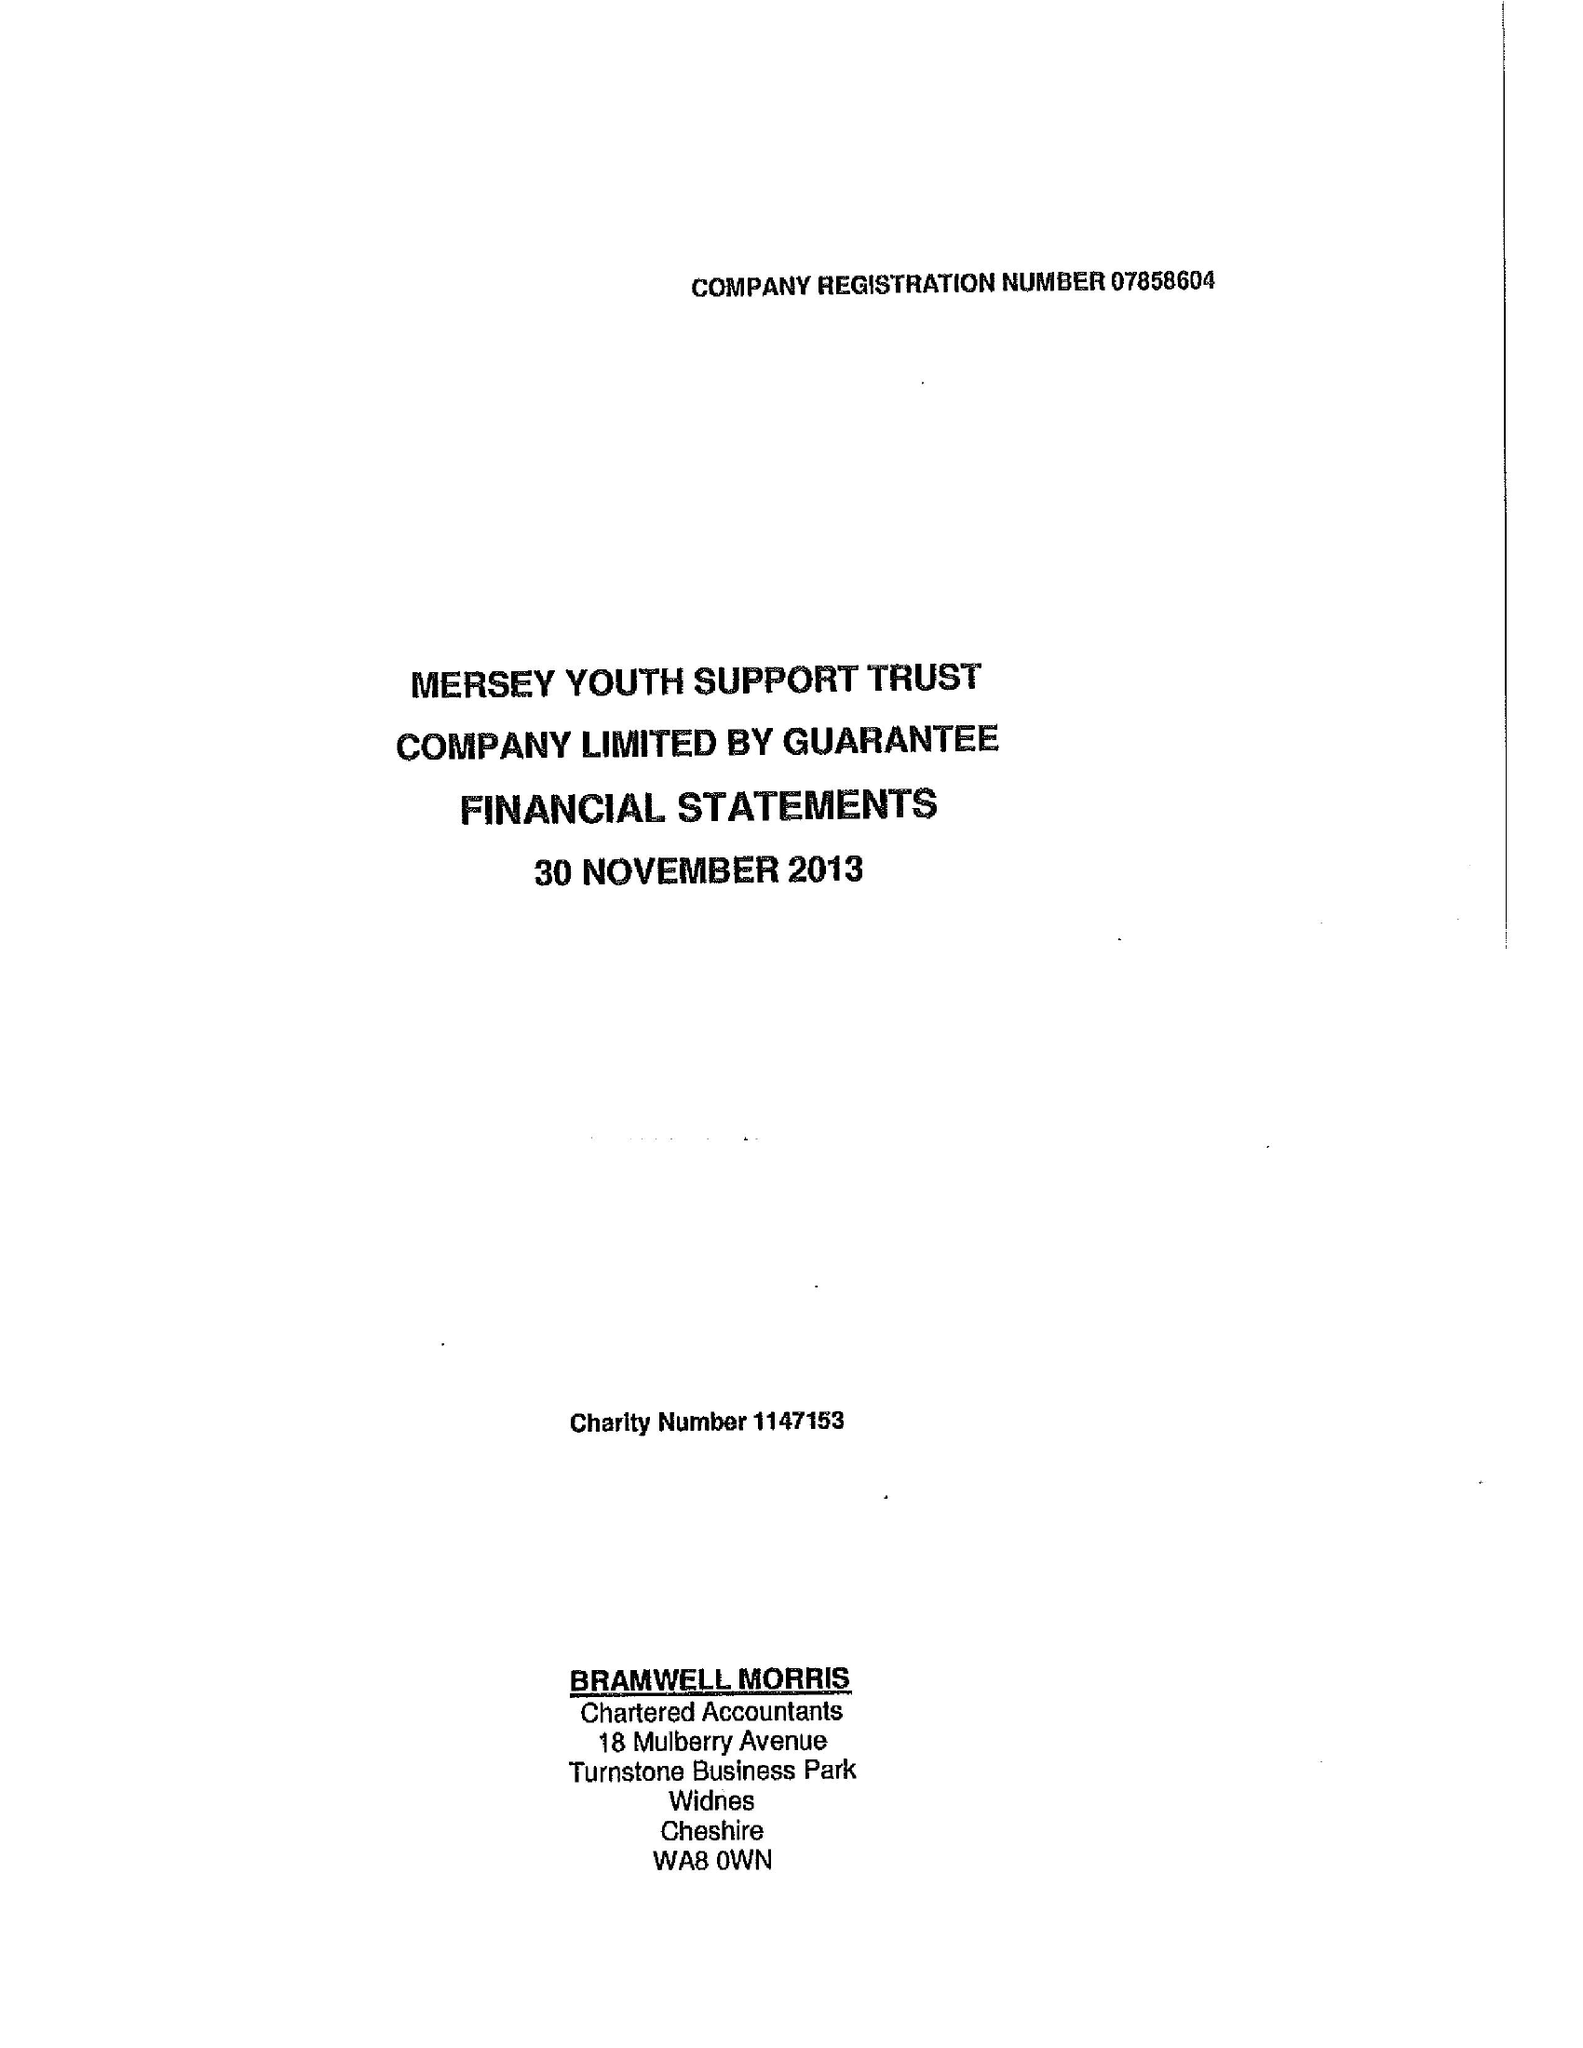What is the value for the address__postcode?
Answer the question using a single word or phrase. L4 3TQ 